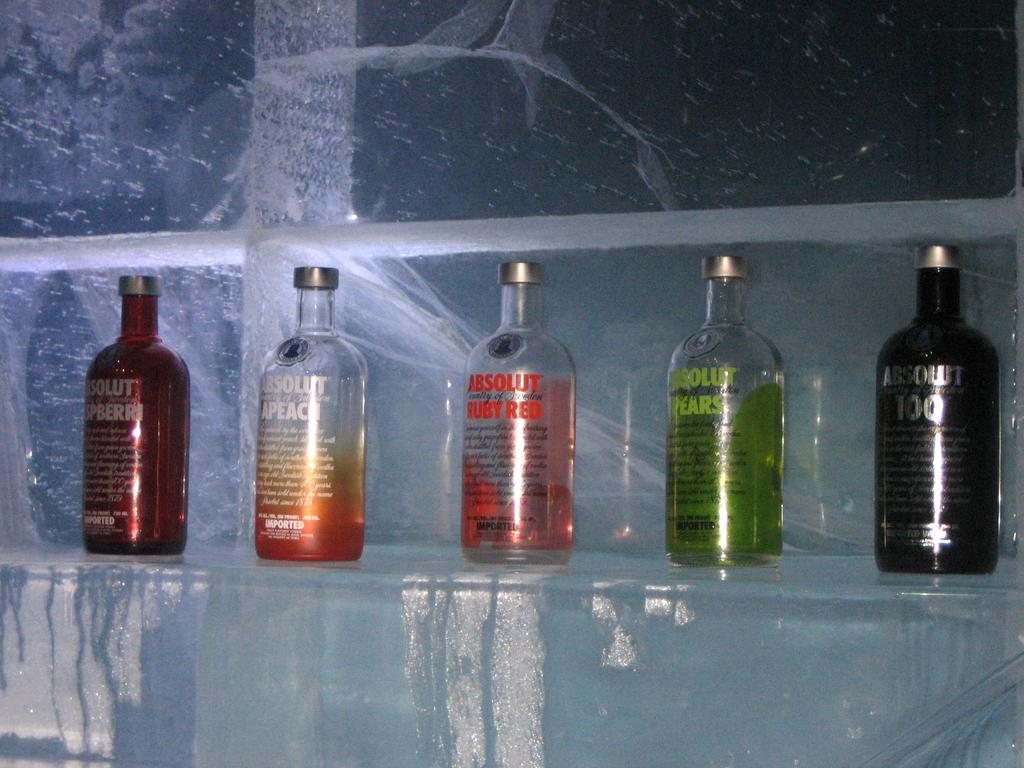<image>
Summarize the visual content of the image. Five different colored of Absolut Vodka sit on a shelf. 